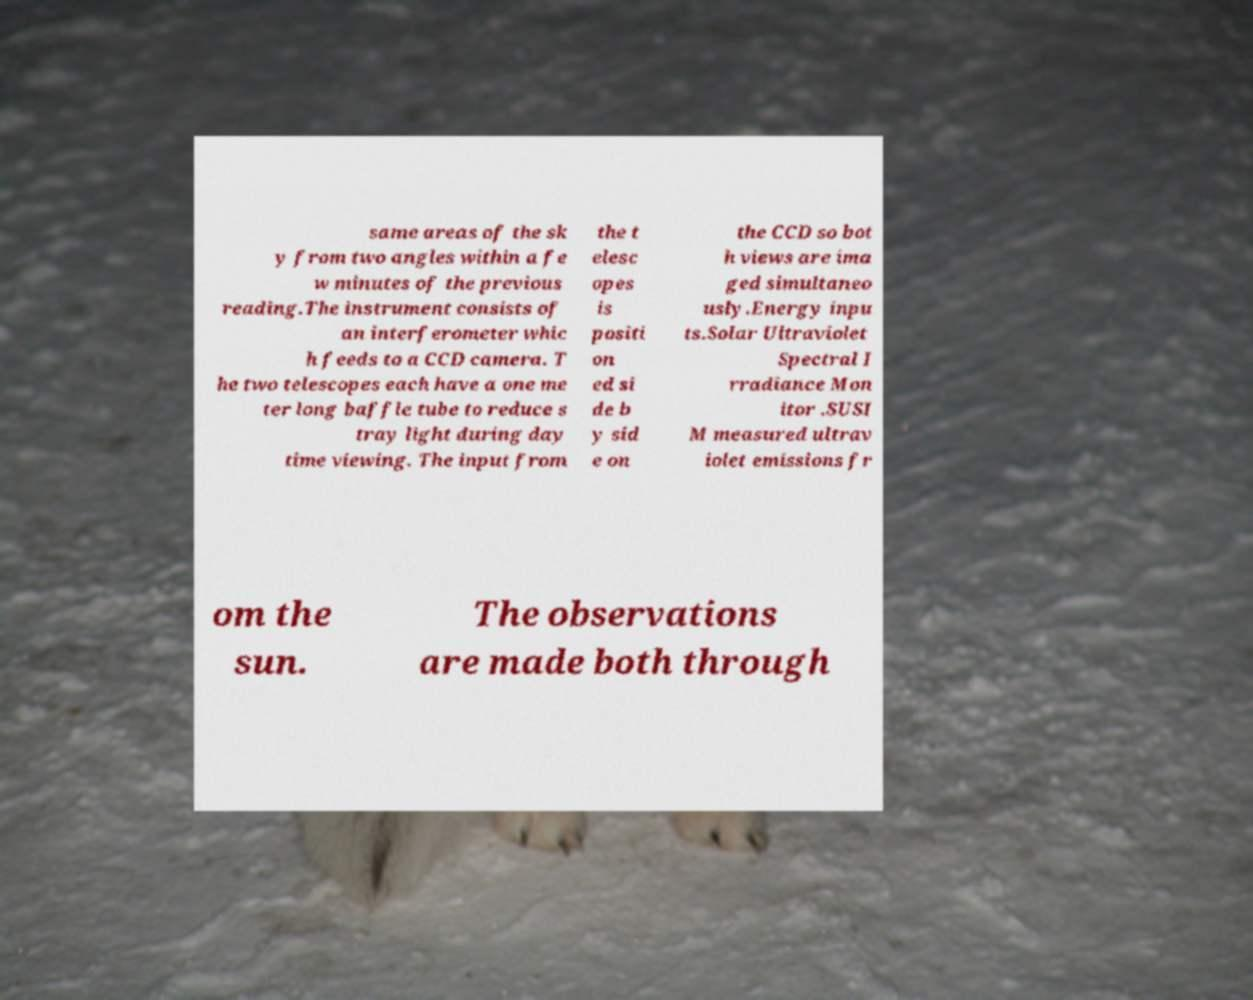What messages or text are displayed in this image? I need them in a readable, typed format. same areas of the sk y from two angles within a fe w minutes of the previous reading.The instrument consists of an interferometer whic h feeds to a CCD camera. T he two telescopes each have a one me ter long baffle tube to reduce s tray light during day time viewing. The input from the t elesc opes is positi on ed si de b y sid e on the CCD so bot h views are ima ged simultaneo usly.Energy inpu ts.Solar Ultraviolet Spectral I rradiance Mon itor .SUSI M measured ultrav iolet emissions fr om the sun. The observations are made both through 